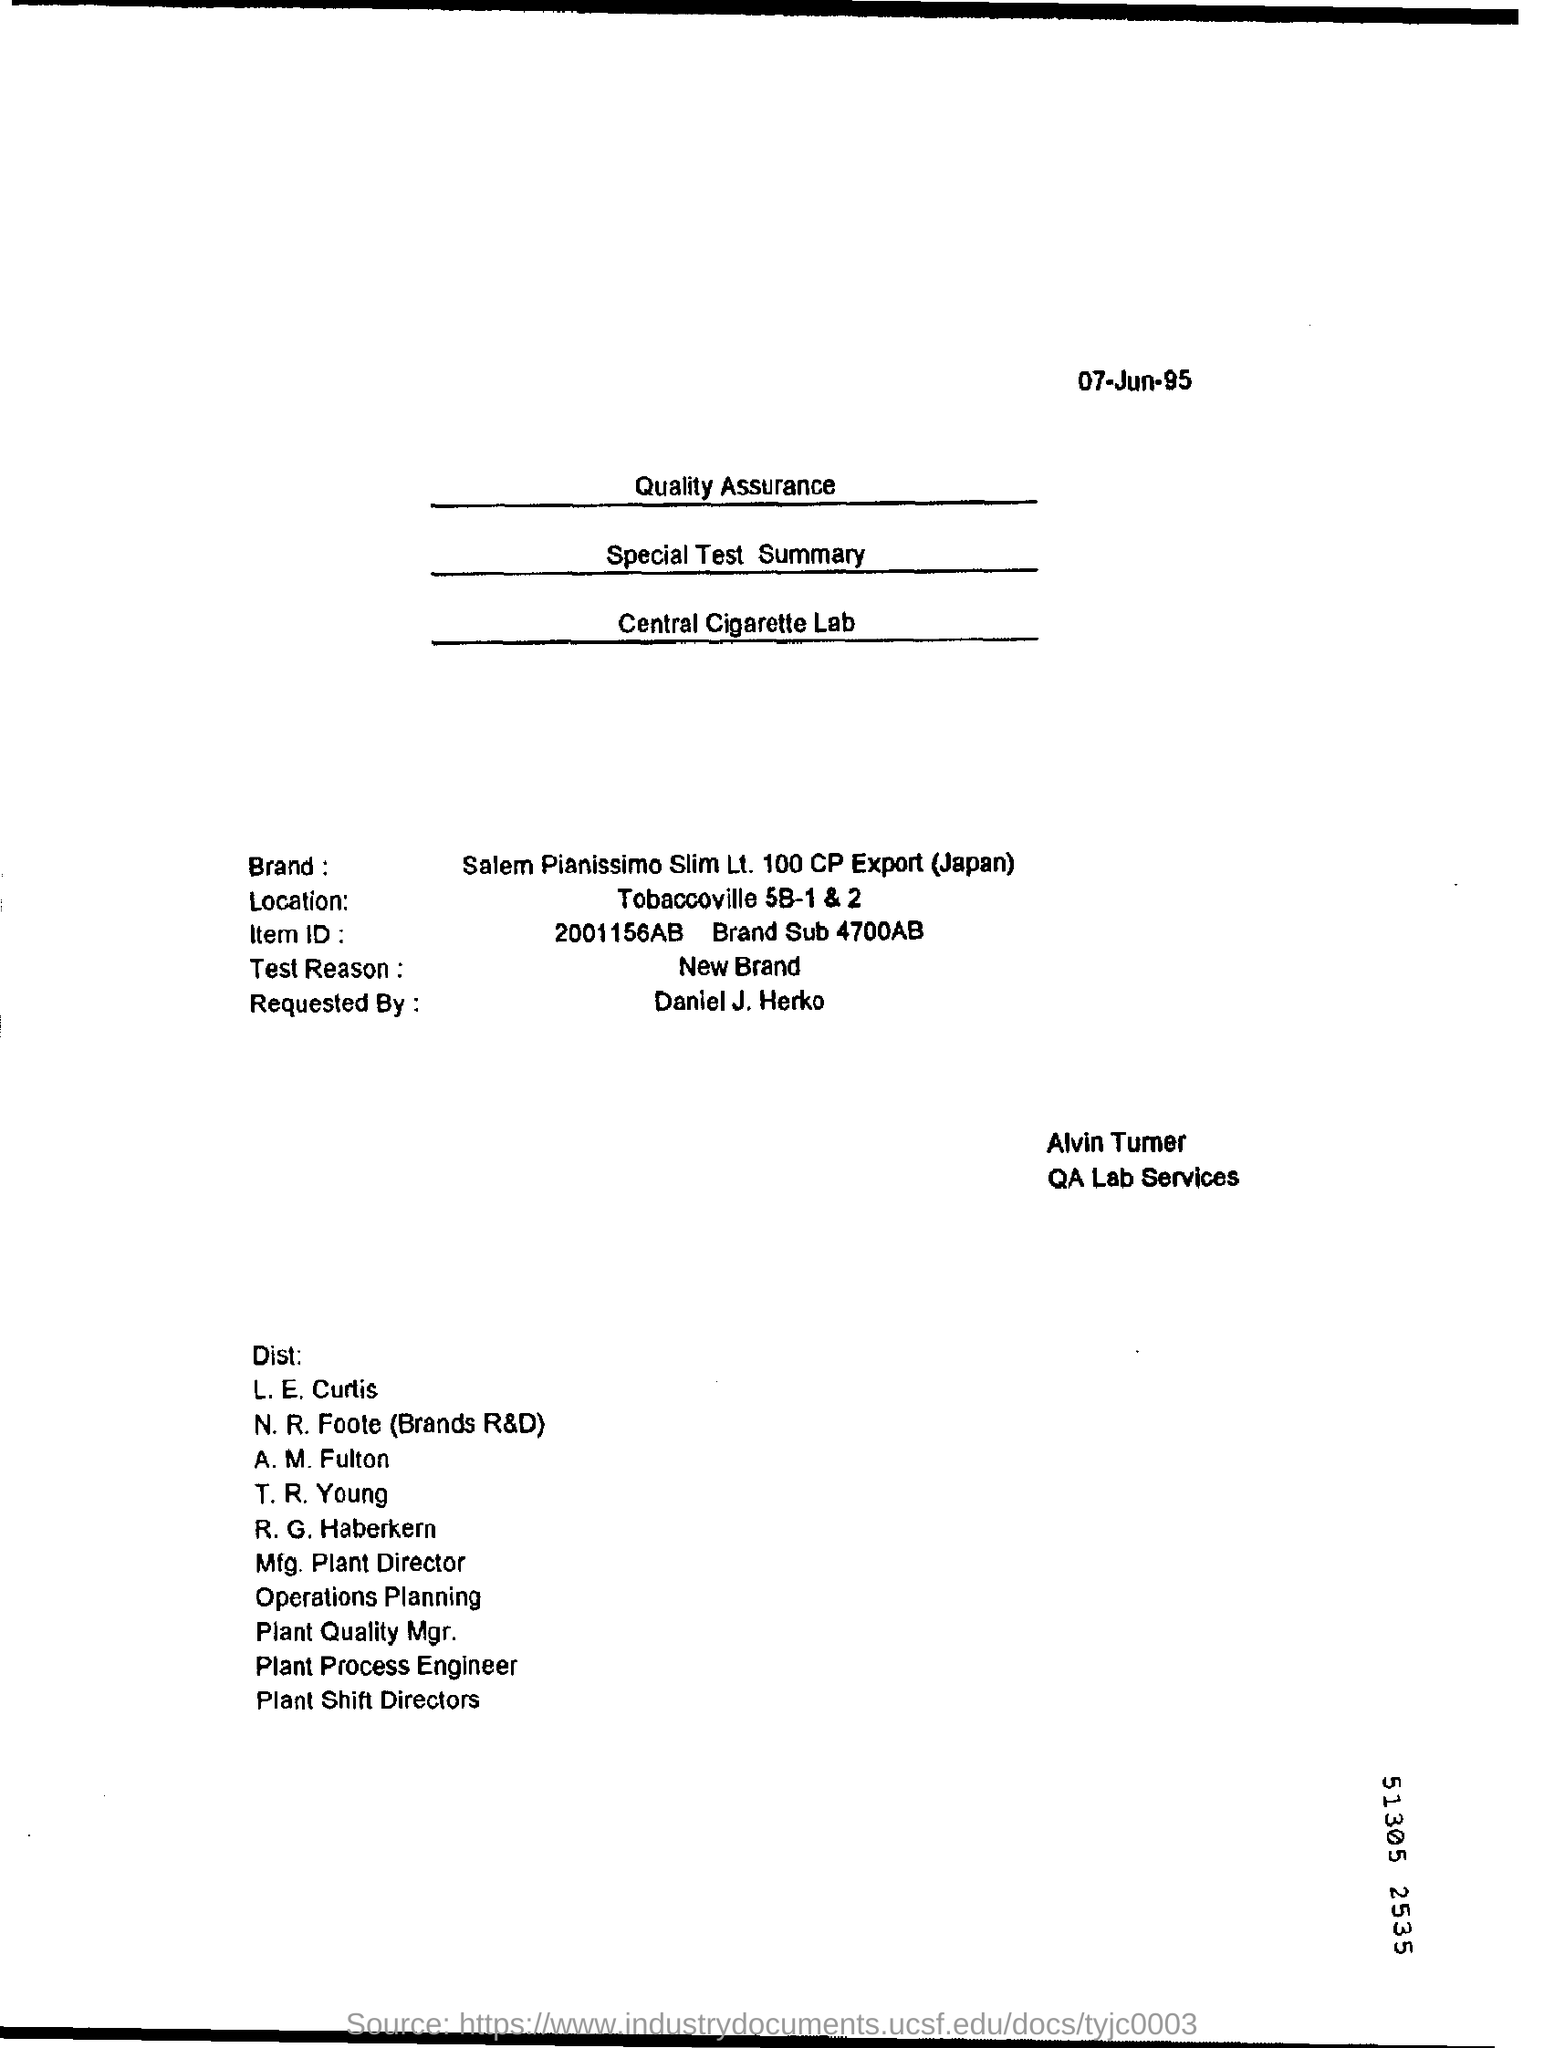Indicate a few pertinent items in this graphic. What is the location of Tobaccoville 5B-1 & 2? The date mentioned in the top of the document is 07-Jun-95. The type of test reason mentioned in this document is a new brand. 